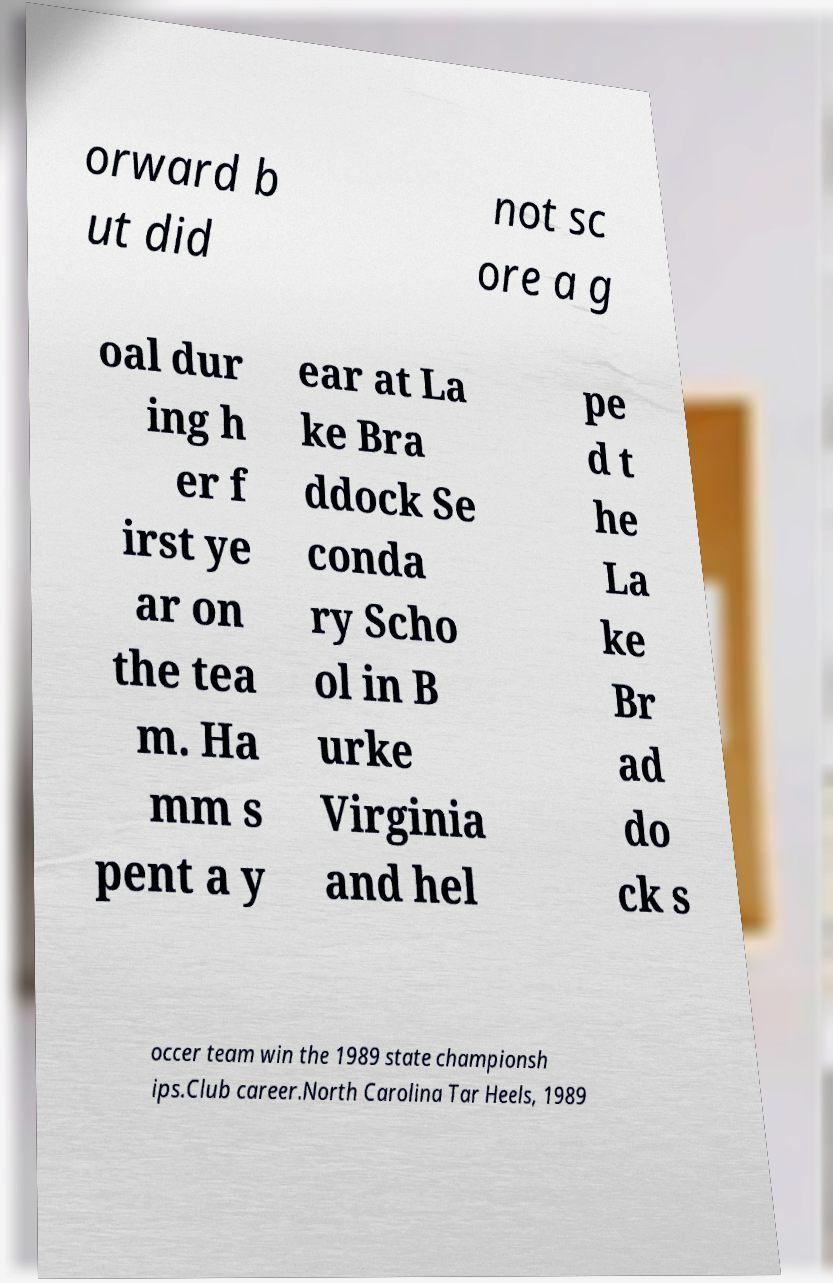Please read and relay the text visible in this image. What does it say? orward b ut did not sc ore a g oal dur ing h er f irst ye ar on the tea m. Ha mm s pent a y ear at La ke Bra ddock Se conda ry Scho ol in B urke Virginia and hel pe d t he La ke Br ad do ck s occer team win the 1989 state championsh ips.Club career.North Carolina Tar Heels, 1989 